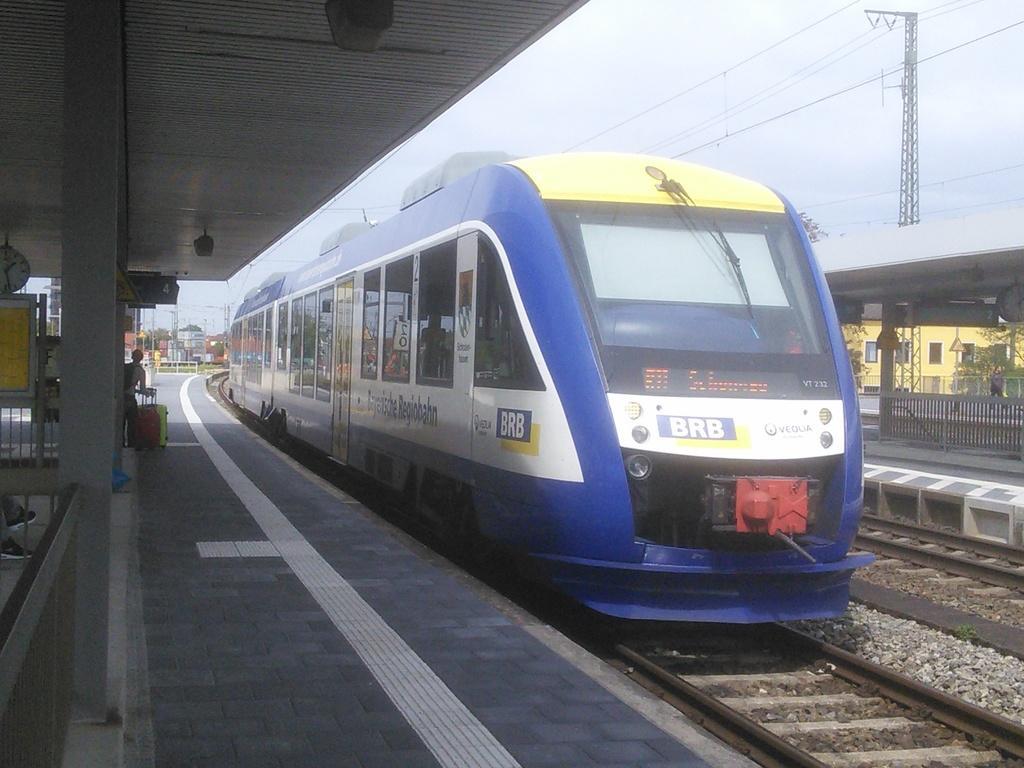Please provide a concise description of this image. In this image in the front there is train with some text written on it. On the left side there are persons and there are luggage bags, there is a pillar and there is a fence. At the top there are objects which are black in colour. On the right side there is a fence and there are trees, and there is a building and there is a tower. In the background there are towers and trees and the sky is cloudy and there are stones in the center. 